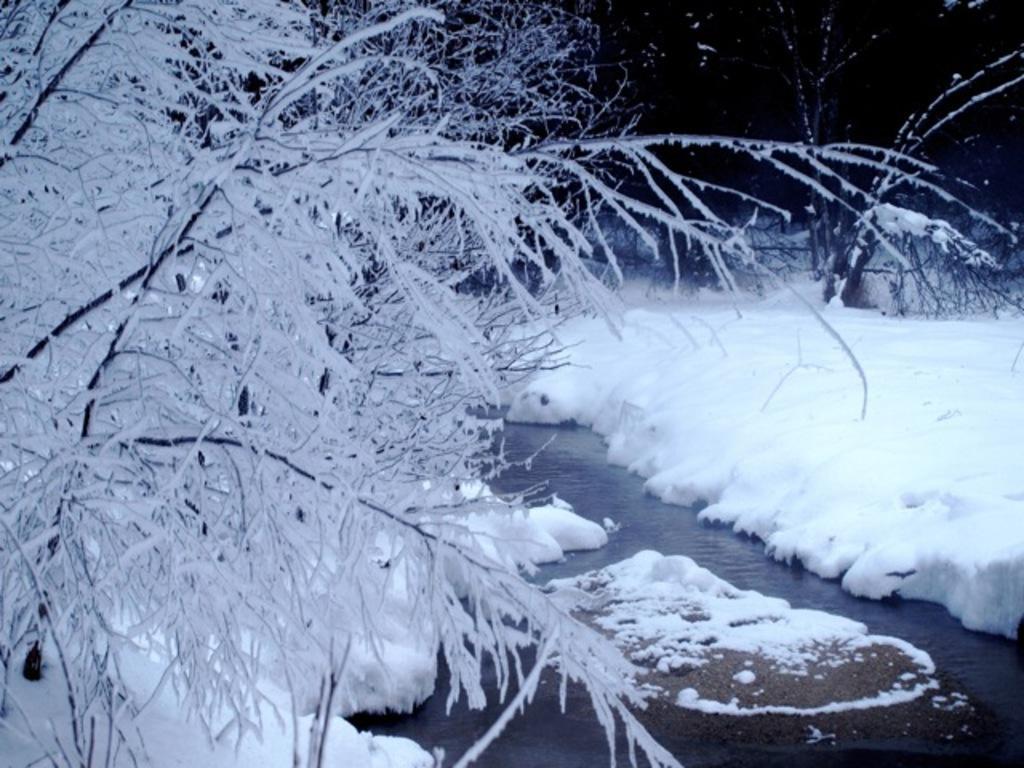In one or two sentences, can you explain what this image depicts? In the image in the center, we can see trees, water and snow. 